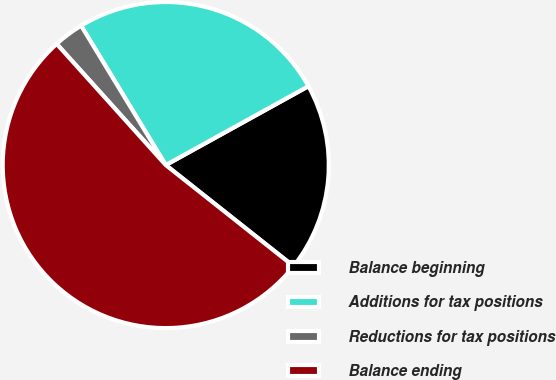<chart> <loc_0><loc_0><loc_500><loc_500><pie_chart><fcel>Balance beginning<fcel>Additions for tax positions<fcel>Reductions for tax positions<fcel>Balance ending<nl><fcel>18.69%<fcel>25.65%<fcel>2.98%<fcel>52.68%<nl></chart> 